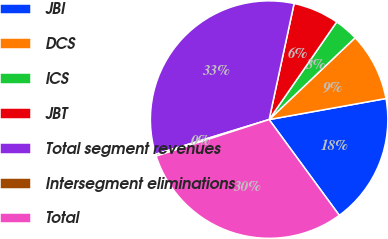Convert chart. <chart><loc_0><loc_0><loc_500><loc_500><pie_chart><fcel>JBI<fcel>DCS<fcel>ICS<fcel>JBT<fcel>Total segment revenues<fcel>Intersegment eliminations<fcel>Total<nl><fcel>17.77%<fcel>9.27%<fcel>3.26%<fcel>6.26%<fcel>33.1%<fcel>0.25%<fcel>30.09%<nl></chart> 